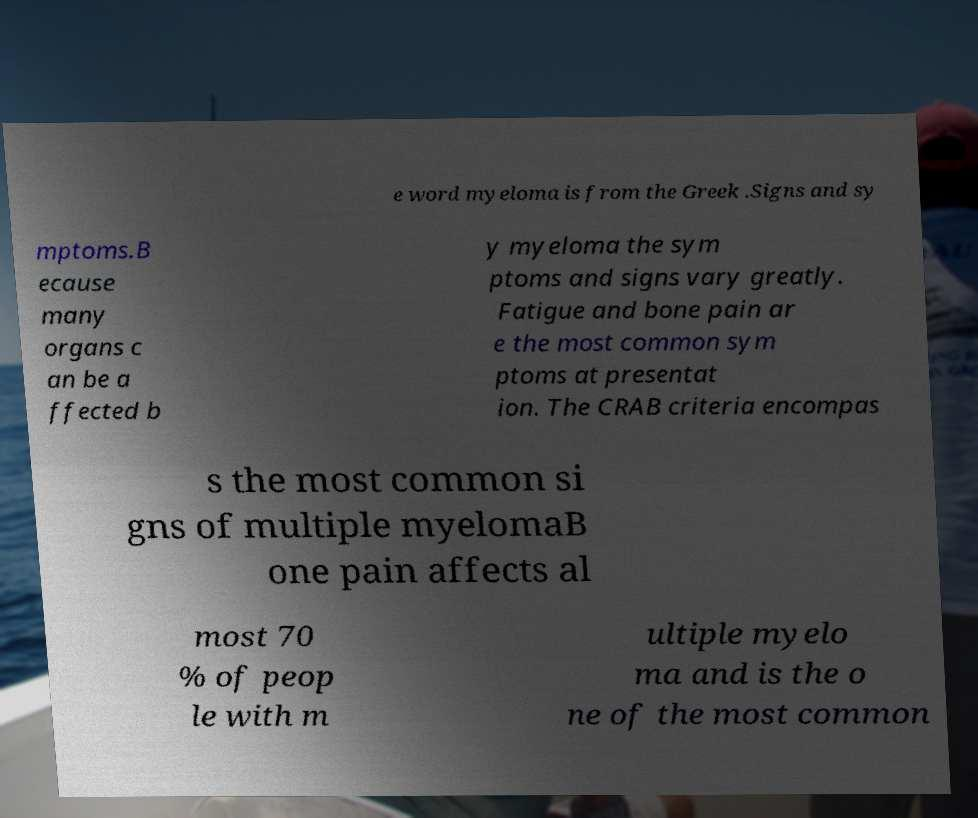What messages or text are displayed in this image? I need them in a readable, typed format. e word myeloma is from the Greek .Signs and sy mptoms.B ecause many organs c an be a ffected b y myeloma the sym ptoms and signs vary greatly. Fatigue and bone pain ar e the most common sym ptoms at presentat ion. The CRAB criteria encompas s the most common si gns of multiple myelomaB one pain affects al most 70 % of peop le with m ultiple myelo ma and is the o ne of the most common 